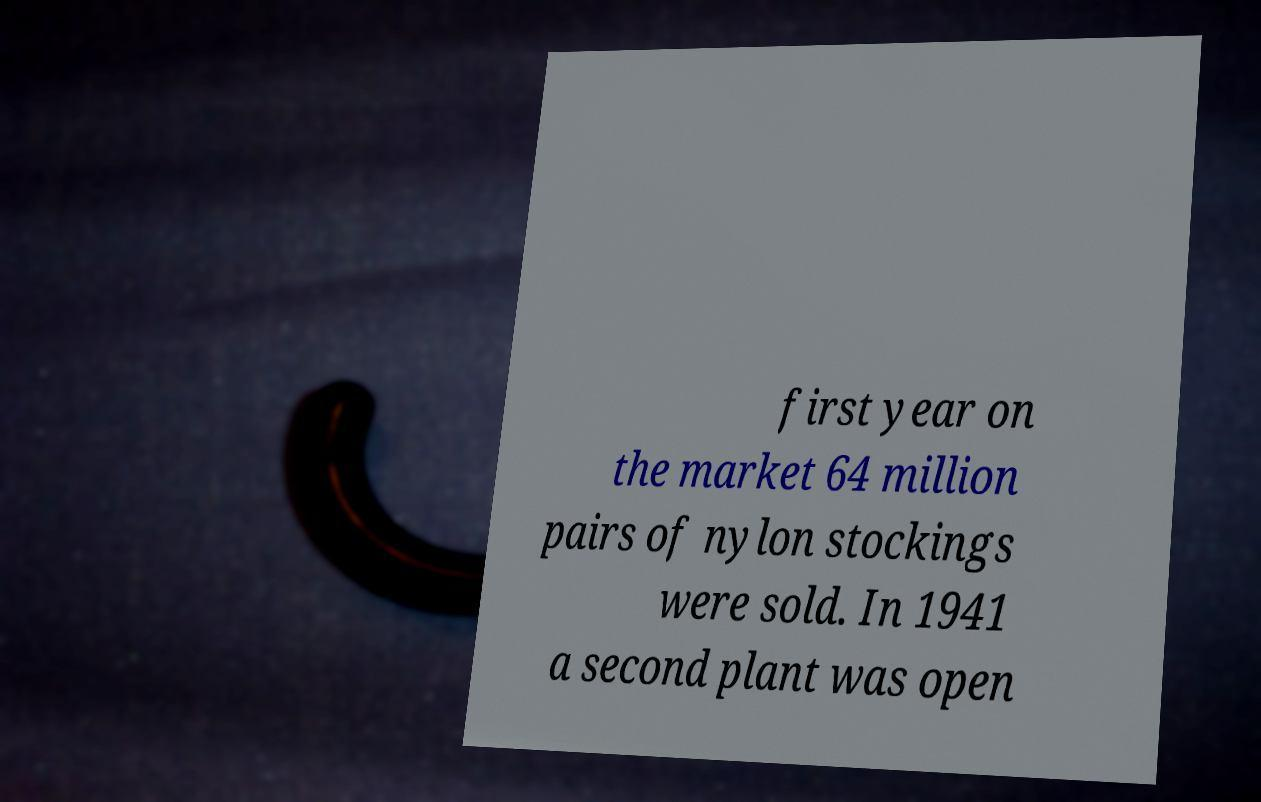Could you extract and type out the text from this image? first year on the market 64 million pairs of nylon stockings were sold. In 1941 a second plant was open 